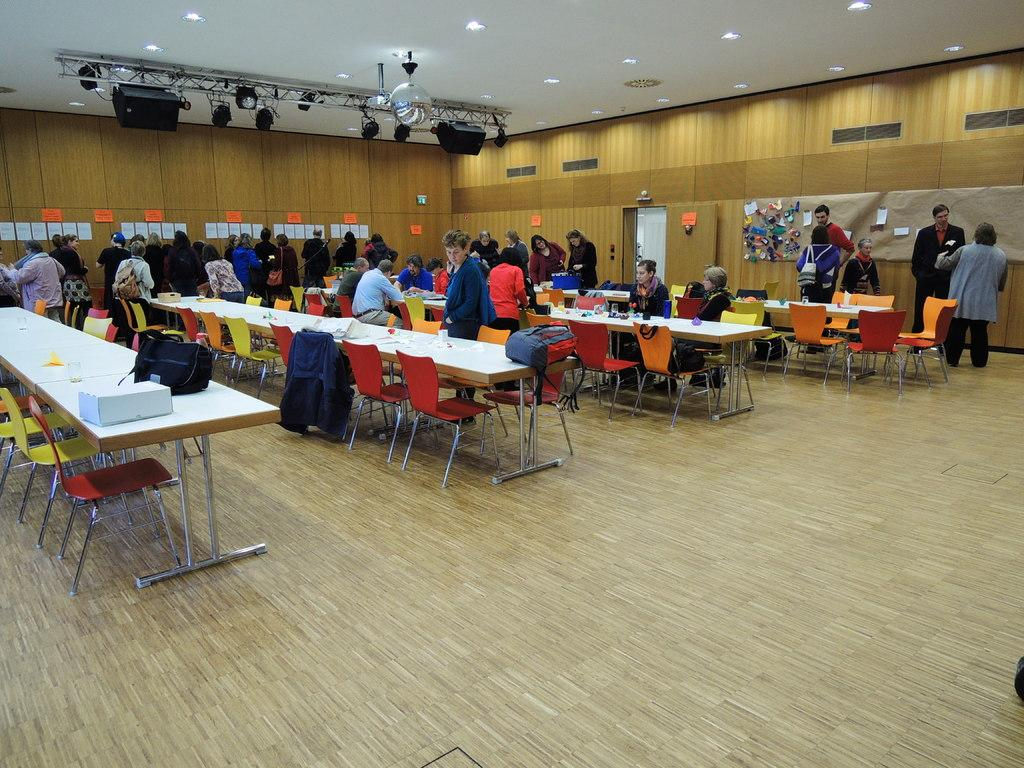What are the people in the image doing? There are people sitting on chairs and people standing in the image. Can you describe the positions of the people in the image? Some people are sitting on chairs, while others are standing. What type of pest can be seen crawling on the people in the image? There are no pests visible in the image; the people are simply sitting or standing. 